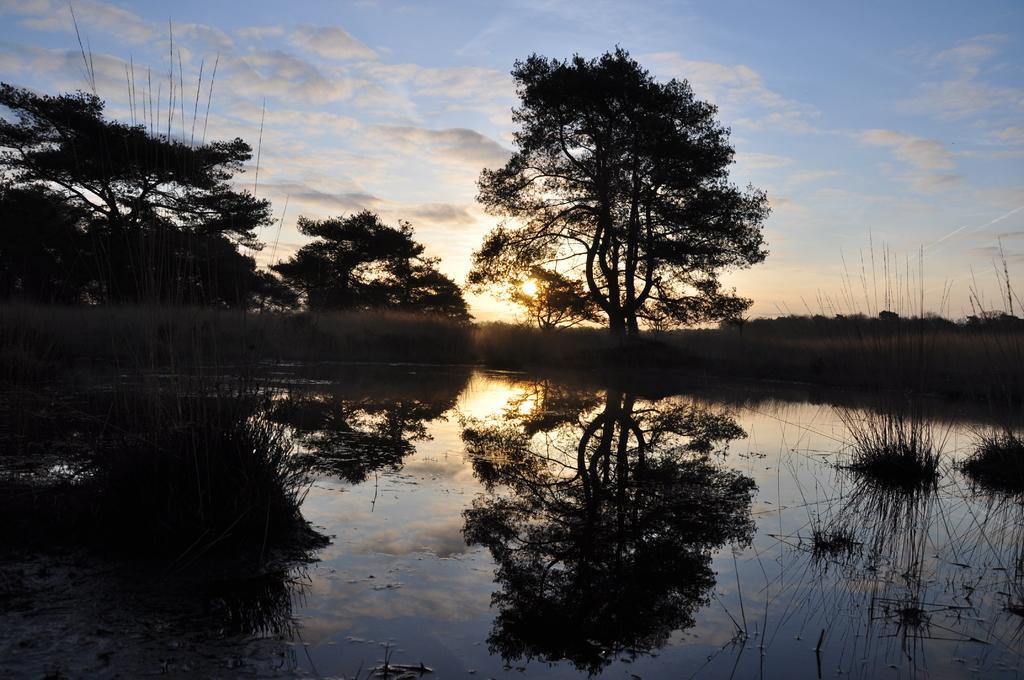Please provide a concise description of this image. In this image I can see at the bottom it looks like a pond. In the middle there are trees, at the top it is the cloudy sky. 